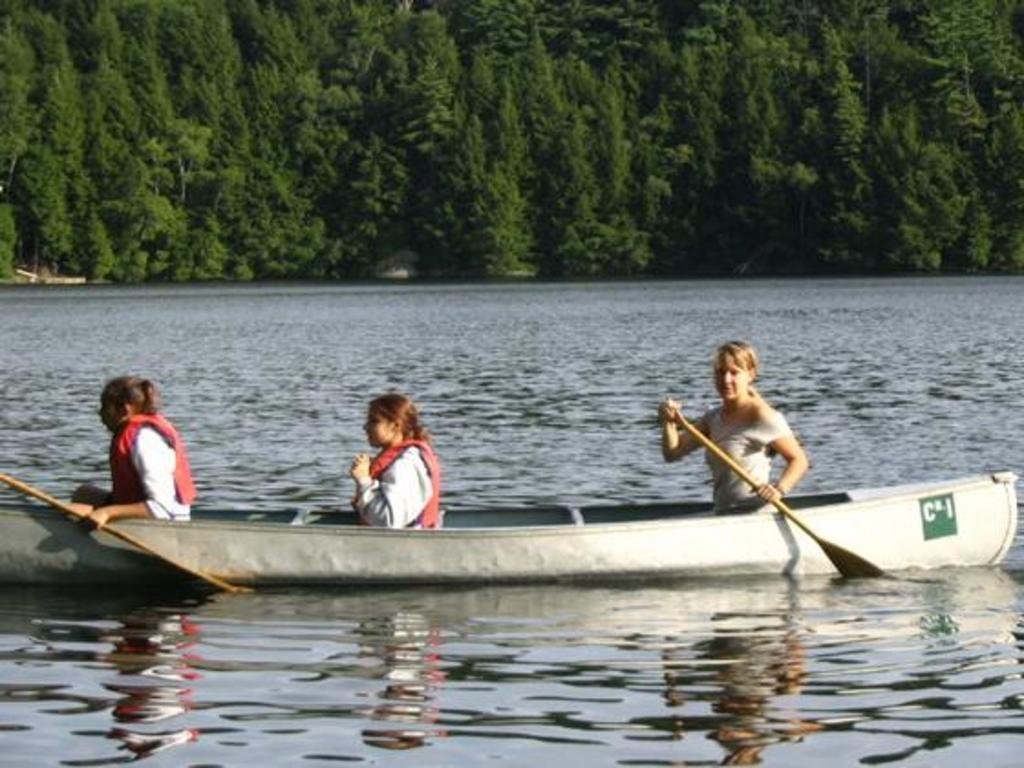How many women are in the image? There are three women in the image. What are the women doing in the image? The women are sitting on a ship. Where is the ship located? The ship is in a lake. What can be seen in the background of the image? There are trees visible in the image. What type of sound can be heard coming from the deer in the image? There are no deer present in the image, so it is not possible to determine what sound, if any, might be heard. 